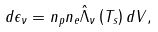Convert formula to latex. <formula><loc_0><loc_0><loc_500><loc_500>d \epsilon _ { \nu } = n _ { p } n _ { e } \hat { \Lambda } _ { \nu } \left ( T _ { s } \right ) d V ,</formula> 